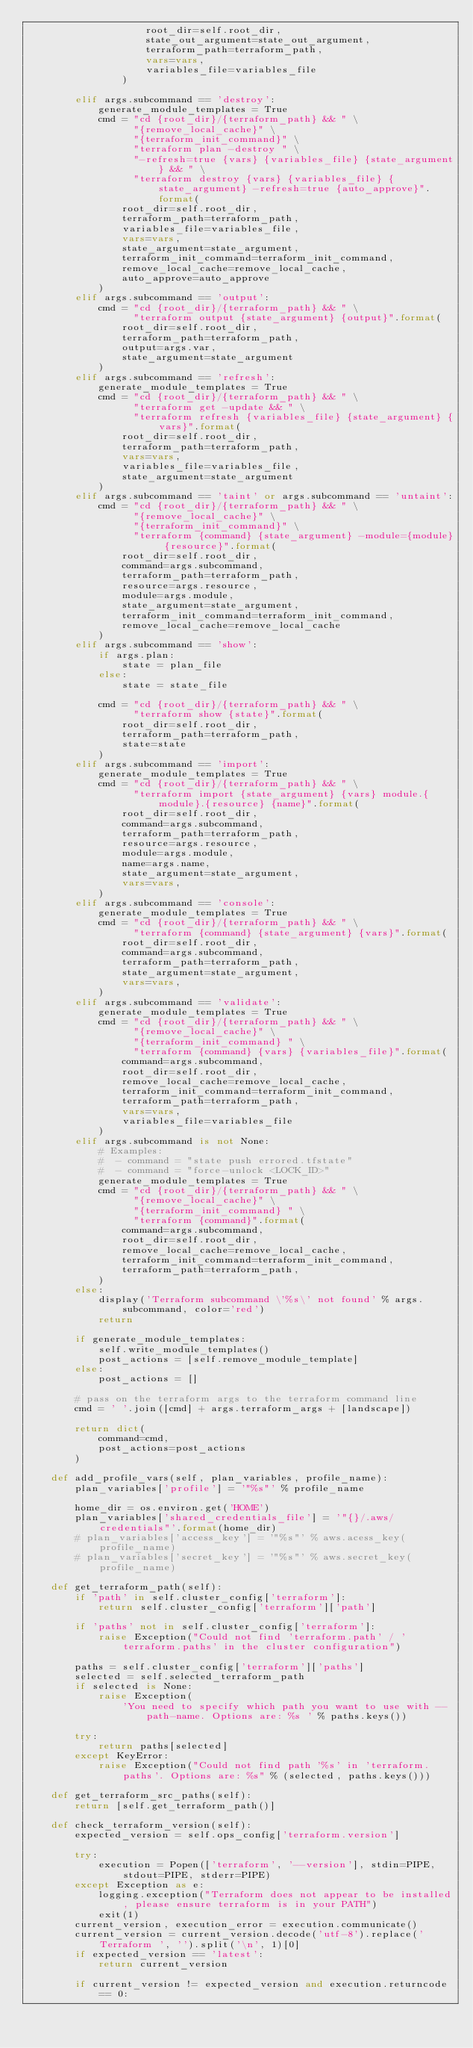<code> <loc_0><loc_0><loc_500><loc_500><_Python_>                    root_dir=self.root_dir,
                    state_out_argument=state_out_argument,
                    terraform_path=terraform_path,
                    vars=vars,
                    variables_file=variables_file
                )

        elif args.subcommand == 'destroy':
            generate_module_templates = True
            cmd = "cd {root_dir}/{terraform_path} && " \
                  "{remove_local_cache}" \
                  "{terraform_init_command}" \
                  "terraform plan -destroy " \
                  "-refresh=true {vars} {variables_file} {state_argument} && " \
                  "terraform destroy {vars} {variables_file} {state_argument} -refresh=true {auto_approve}".format(
                root_dir=self.root_dir,
                terraform_path=terraform_path,
                variables_file=variables_file,
                vars=vars,
                state_argument=state_argument,
                terraform_init_command=terraform_init_command,
                remove_local_cache=remove_local_cache,
                auto_approve=auto_approve
            )
        elif args.subcommand == 'output':
            cmd = "cd {root_dir}/{terraform_path} && " \
                  "terraform output {state_argument} {output}".format(
                root_dir=self.root_dir,
                terraform_path=terraform_path,
                output=args.var,
                state_argument=state_argument
            )
        elif args.subcommand == 'refresh':
            generate_module_templates = True
            cmd = "cd {root_dir}/{terraform_path} && " \
                  "terraform get -update && " \
                  "terraform refresh {variables_file} {state_argument} {vars}".format(
                root_dir=self.root_dir,
                terraform_path=terraform_path,
                vars=vars,
                variables_file=variables_file,
                state_argument=state_argument
            )
        elif args.subcommand == 'taint' or args.subcommand == 'untaint':
            cmd = "cd {root_dir}/{terraform_path} && " \
                  "{remove_local_cache}" \
                  "{terraform_init_command}" \
                  "terraform {command} {state_argument} -module={module} {resource}".format(
                root_dir=self.root_dir,
                command=args.subcommand,
                terraform_path=terraform_path,
                resource=args.resource,
                module=args.module,
                state_argument=state_argument,
                terraform_init_command=terraform_init_command,
                remove_local_cache=remove_local_cache
            )
        elif args.subcommand == 'show':
            if args.plan:
                state = plan_file
            else:
                state = state_file

            cmd = "cd {root_dir}/{terraform_path} && " \
                  "terraform show {state}".format(
                root_dir=self.root_dir,
                terraform_path=terraform_path,
                state=state
            )
        elif args.subcommand == 'import':
            generate_module_templates = True
            cmd = "cd {root_dir}/{terraform_path} && " \
                  "terraform import {state_argument} {vars} module.{module}.{resource} {name}".format(
                root_dir=self.root_dir,
                command=args.subcommand,
                terraform_path=terraform_path,
                resource=args.resource,
                module=args.module,
                name=args.name,
                state_argument=state_argument,
                vars=vars,
            )
        elif args.subcommand == 'console':
            generate_module_templates = True
            cmd = "cd {root_dir}/{terraform_path} && " \
                  "terraform {command} {state_argument} {vars}".format(
                root_dir=self.root_dir,
                command=args.subcommand,
                terraform_path=terraform_path,
                state_argument=state_argument,
                vars=vars,
            )
        elif args.subcommand == 'validate':
            generate_module_templates = True
            cmd = "cd {root_dir}/{terraform_path} && " \
                  "{remove_local_cache}" \
                  "{terraform_init_command} " \
                  "terraform {command} {vars} {variables_file}".format(
                command=args.subcommand,
                root_dir=self.root_dir,
                remove_local_cache=remove_local_cache,
                terraform_init_command=terraform_init_command,
                terraform_path=terraform_path,
                vars=vars,
                variables_file=variables_file
            )
        elif args.subcommand is not None:
            # Examples:
            #  - command = "state push errored.tfstate"
            #  - command = "force-unlock <LOCK_ID>"
            generate_module_templates = True
            cmd = "cd {root_dir}/{terraform_path} && " \
                  "{remove_local_cache}" \
                  "{terraform_init_command} " \
                  "terraform {command}".format(
                command=args.subcommand,
                root_dir=self.root_dir,
                remove_local_cache=remove_local_cache,
                terraform_init_command=terraform_init_command,
                terraform_path=terraform_path,
            )
        else:
            display('Terraform subcommand \'%s\' not found' % args.subcommand, color='red')
            return

        if generate_module_templates:
            self.write_module_templates()
            post_actions = [self.remove_module_template]
        else:
            post_actions = []

        # pass on the terraform args to the terraform command line
        cmd = ' '.join([cmd] + args.terraform_args + [landscape])

        return dict(
            command=cmd,
            post_actions=post_actions
        )

    def add_profile_vars(self, plan_variables, profile_name):
        plan_variables['profile'] = '"%s"' % profile_name

        home_dir = os.environ.get('HOME')
        plan_variables['shared_credentials_file'] = '"{}/.aws/credentials"'.format(home_dir)
        # plan_variables['access_key'] = '"%s"' % aws.acess_key(profile_name)
        # plan_variables['secret_key'] = '"%s"' % aws.secret_key(profile_name)

    def get_terraform_path(self):
        if 'path' in self.cluster_config['terraform']:
            return self.cluster_config['terraform']['path']

        if 'paths' not in self.cluster_config['terraform']:
            raise Exception("Could not find 'terraform.path' / 'terraform.paths' in the cluster configuration")

        paths = self.cluster_config['terraform']['paths']
        selected = self.selected_terraform_path
        if selected is None:
            raise Exception(
                'You need to specify which path you want to use with --path-name. Options are: %s ' % paths.keys())

        try:
            return paths[selected]
        except KeyError:
            raise Exception("Could not find path '%s' in 'terraform.paths'. Options are: %s" % (selected, paths.keys()))

    def get_terraform_src_paths(self):
        return [self.get_terraform_path()]

    def check_terraform_version(self):
        expected_version = self.ops_config['terraform.version']

        try:
            execution = Popen(['terraform', '--version'], stdin=PIPE, stdout=PIPE, stderr=PIPE)
        except Exception as e:
            logging.exception("Terraform does not appear to be installed, please ensure terraform is in your PATH")
            exit(1)
        current_version, execution_error = execution.communicate()
        current_version = current_version.decode('utf-8').replace('Terraform ', '').split('\n', 1)[0]
        if expected_version == 'latest':
            return current_version

        if current_version != expected_version and execution.returncode == 0:</code> 